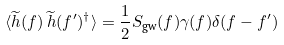<formula> <loc_0><loc_0><loc_500><loc_500>\langle \widetilde { h } ( f ) \, \widetilde { h } ( f ^ { \prime } ) ^ { \dagger } \rangle = \frac { 1 } { 2 } S _ { \text {gw} } ( f ) \gamma ( f ) \delta ( f - f ^ { \prime } )</formula> 